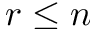<formula> <loc_0><loc_0><loc_500><loc_500>r \leq n</formula> 